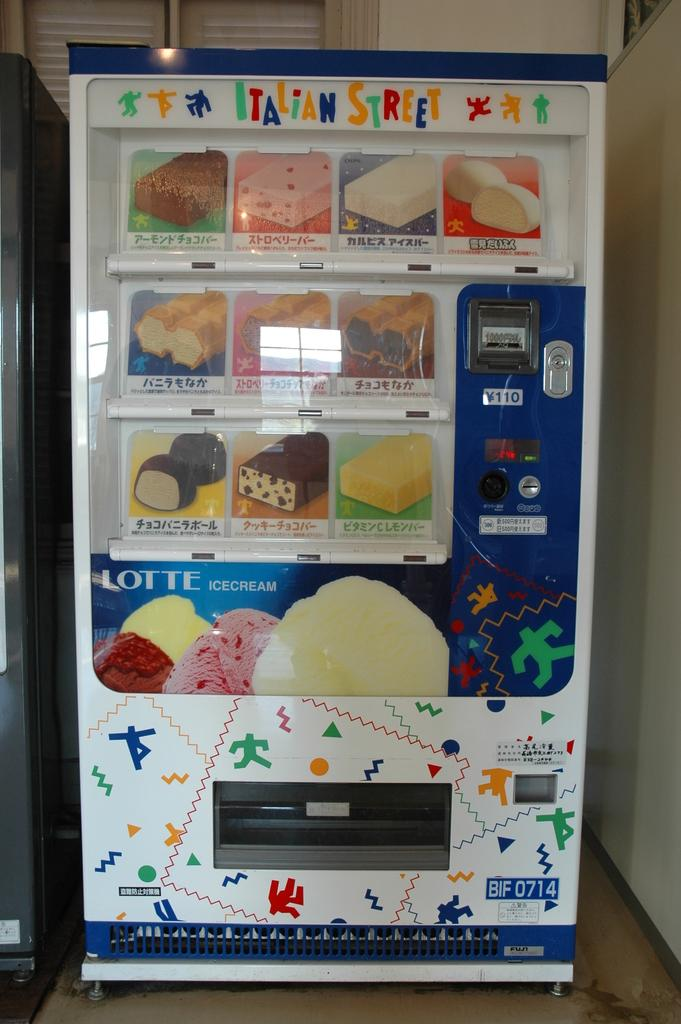<image>
Summarize the visual content of the image. A vending machine that serves LOTTE ice cream. 